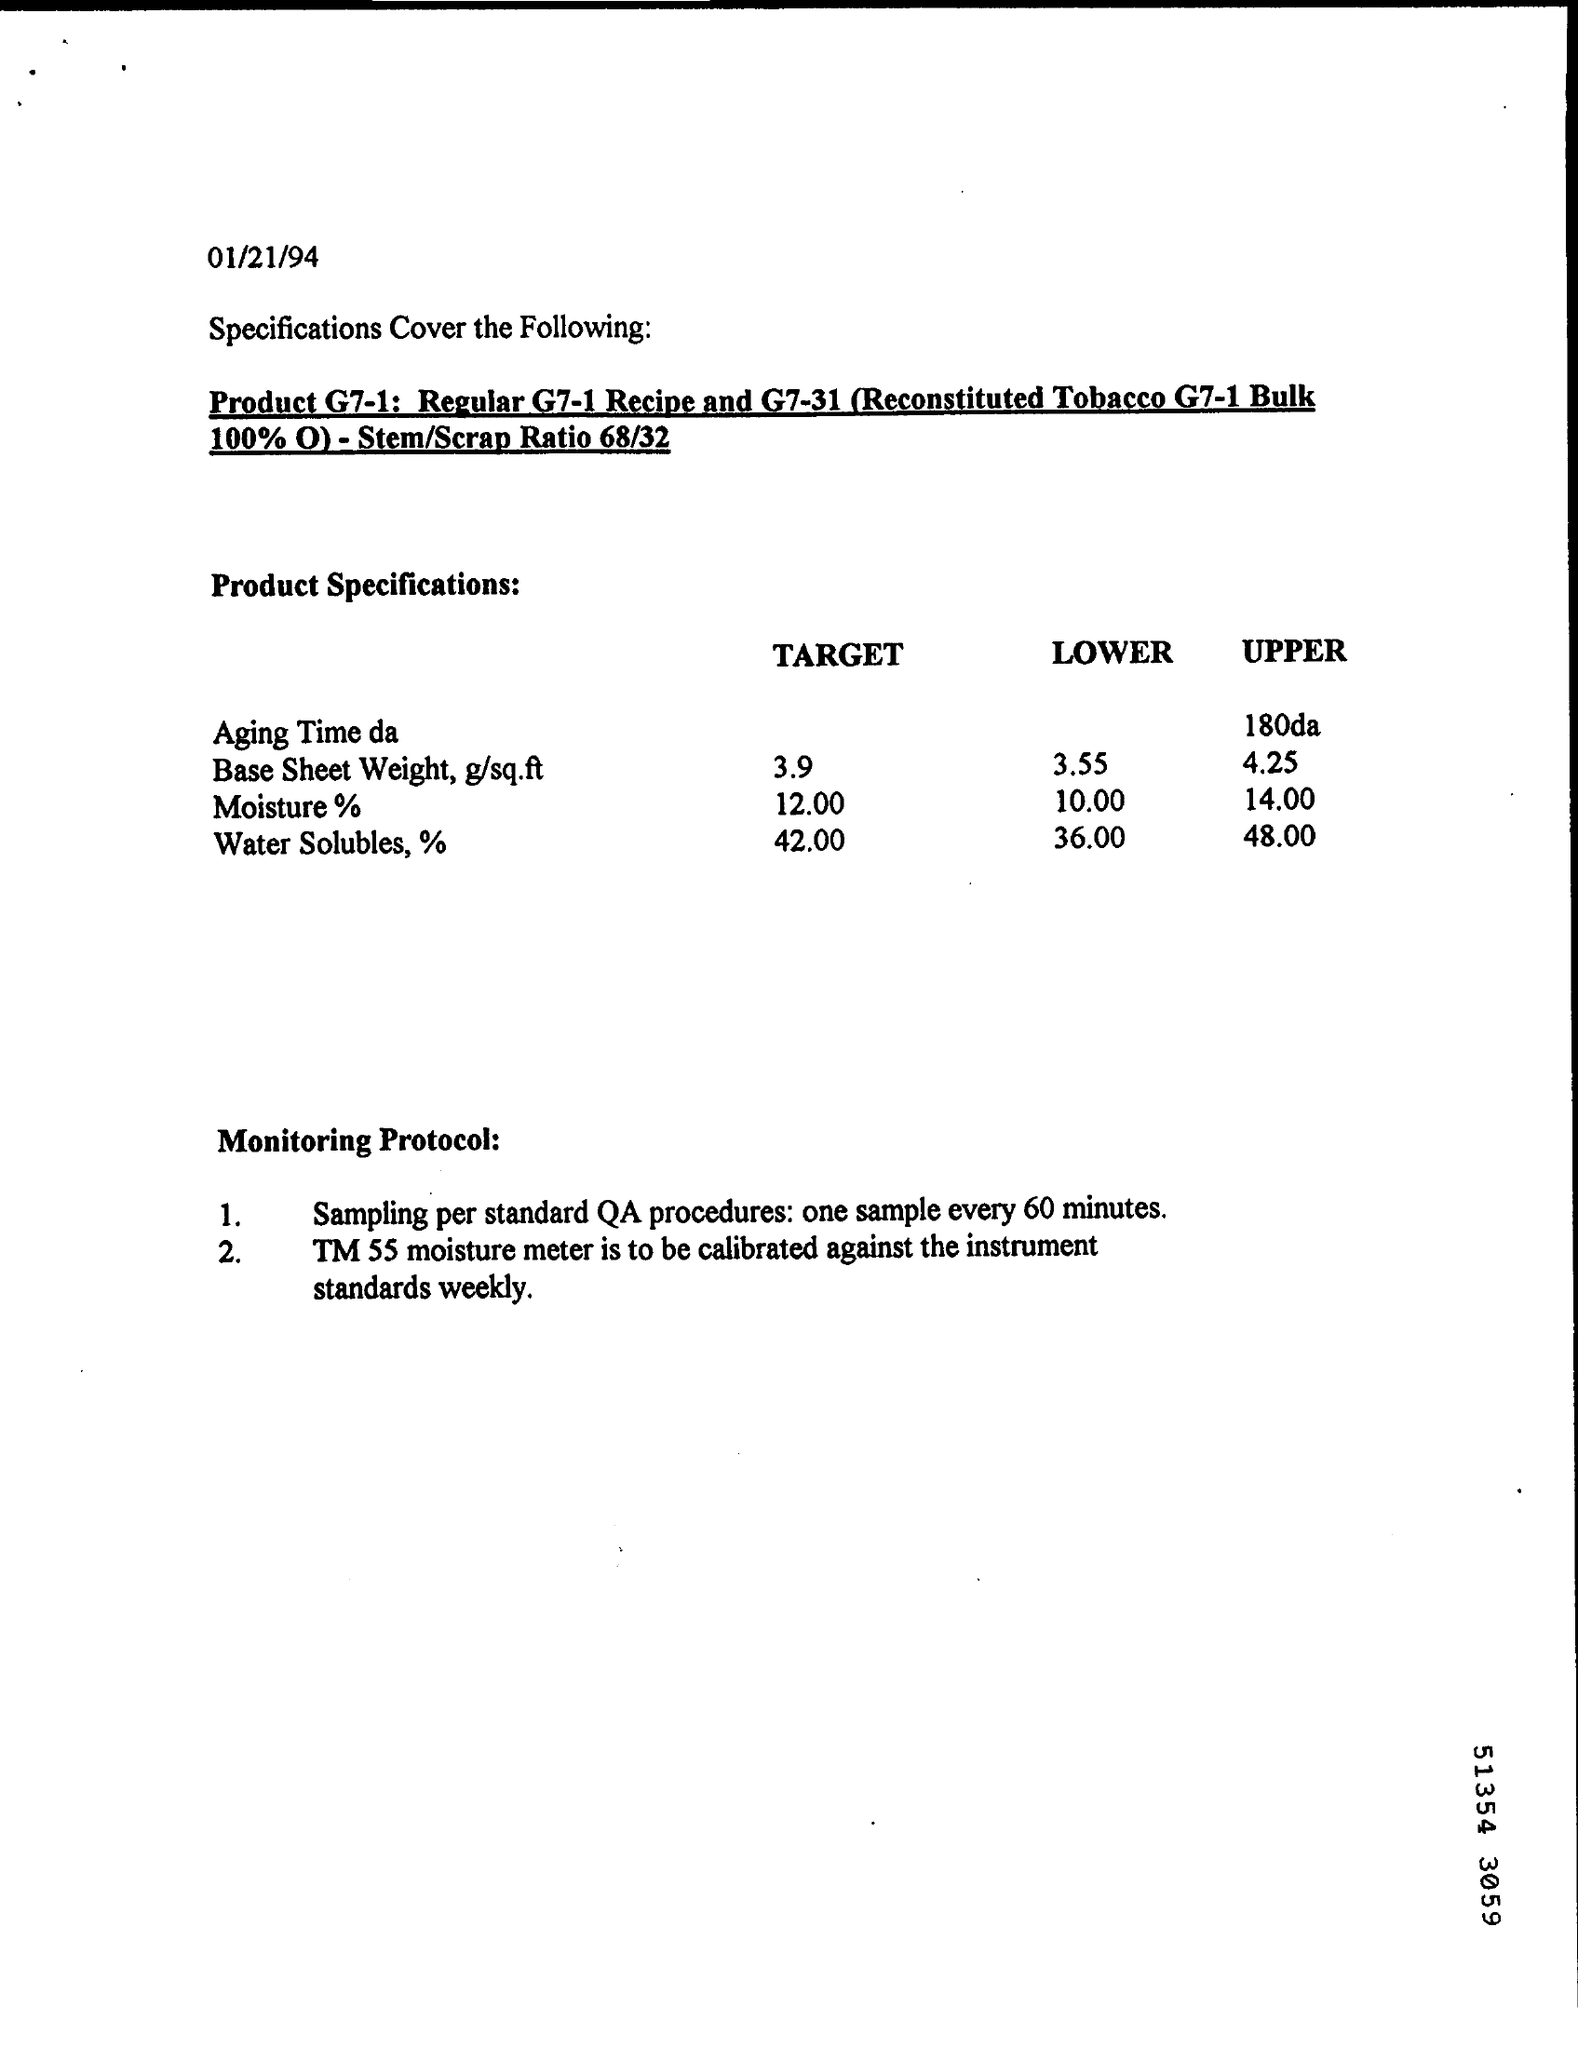What is the date mentioned?
Give a very brief answer. 01/21/94. What is the Target of Water Solubles, %?
Your response must be concise. 42.00. What is the LOWER of Moisture %?
Offer a very short reply. 10.00. 